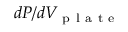Convert formula to latex. <formula><loc_0><loc_0><loc_500><loc_500>d P / d V _ { p l a t e }</formula> 